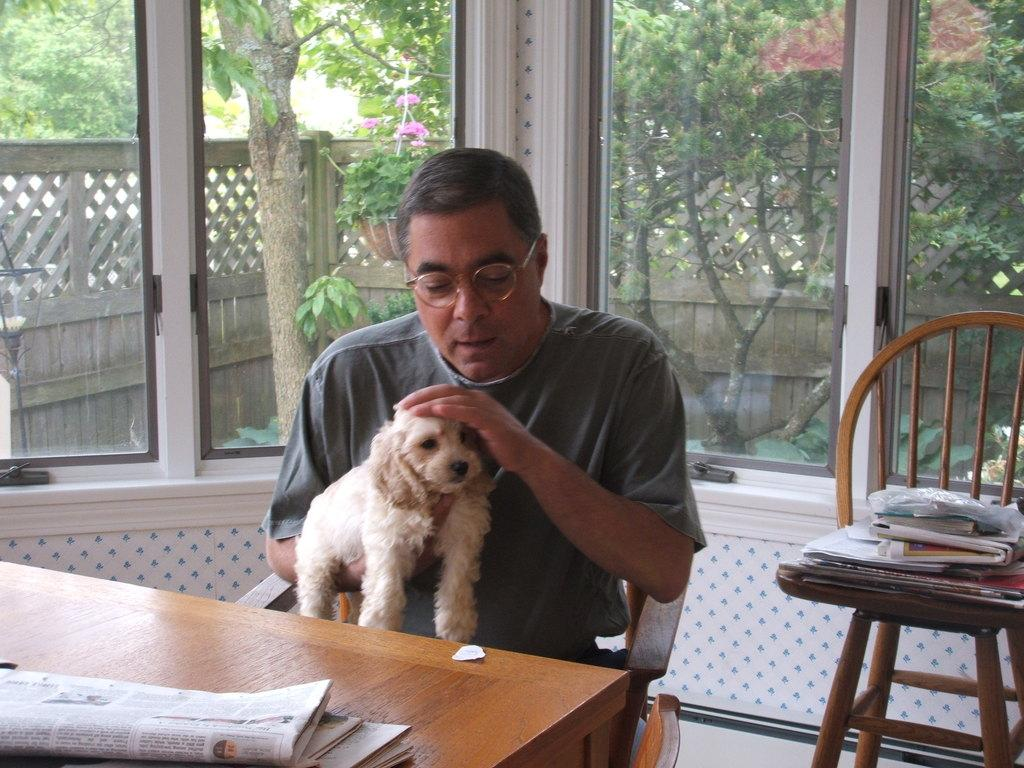What is the man in the image doing? The man is sitting on a chair in the image. What is the man holding in the image? The man is holding a dog in the image. What object can be seen on the table in the image? There is a paper on the table in the image. What can be seen in the background of the image? There are trees in the background of the image. What type of ship can be seen sailing in the background of the image? There is no ship visible in the image; it only shows a man sitting on a chair holding a dog, a paper on the table, and trees in the background. 